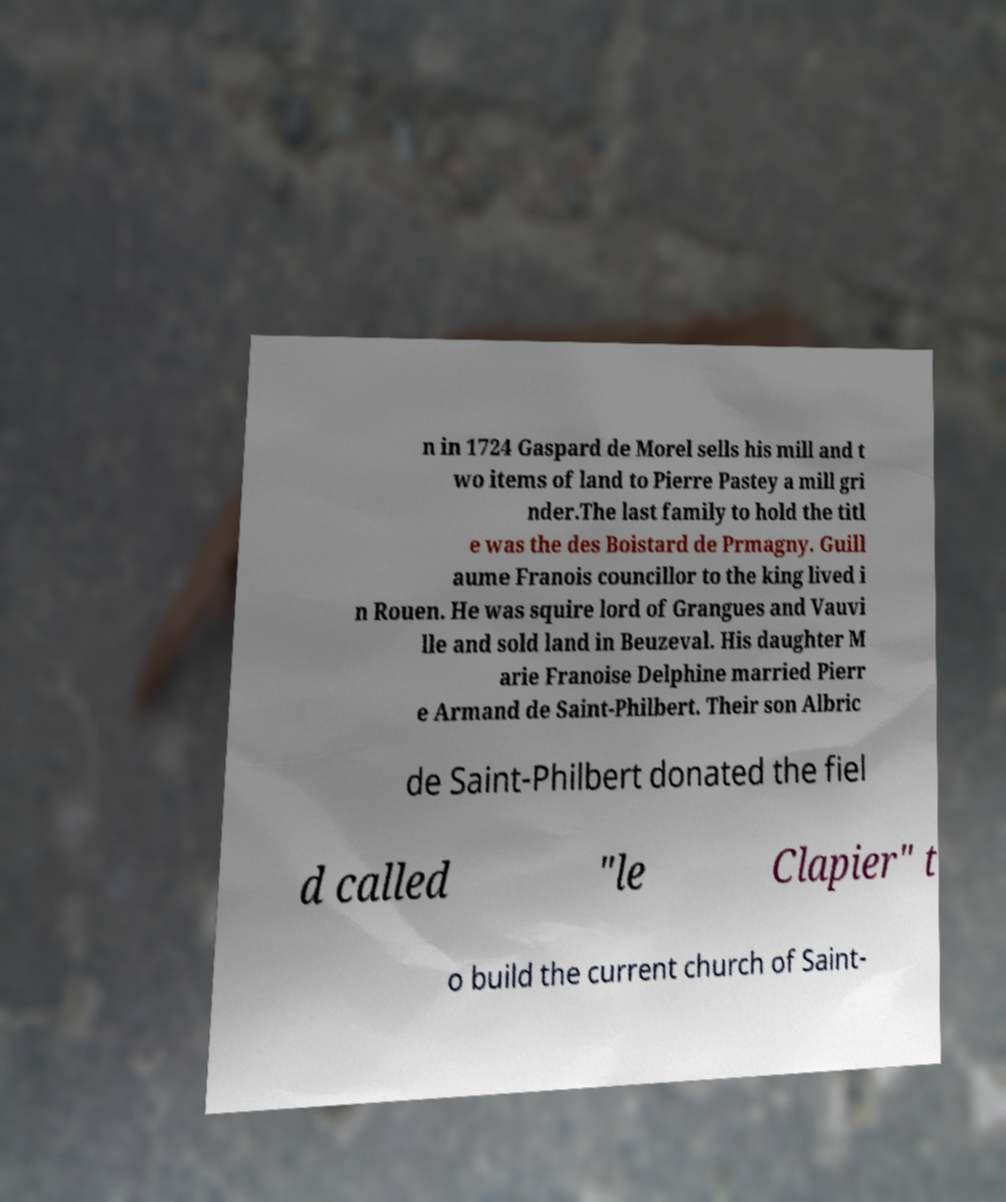I need the written content from this picture converted into text. Can you do that? n in 1724 Gaspard de Morel sells his mill and t wo items of land to Pierre Pastey a mill gri nder.The last family to hold the titl e was the des Boistard de Prmagny. Guill aume Franois councillor to the king lived i n Rouen. He was squire lord of Grangues and Vauvi lle and sold land in Beuzeval. His daughter M arie Franoise Delphine married Pierr e Armand de Saint-Philbert. Their son Albric de Saint-Philbert donated the fiel d called "le Clapier" t o build the current church of Saint- 